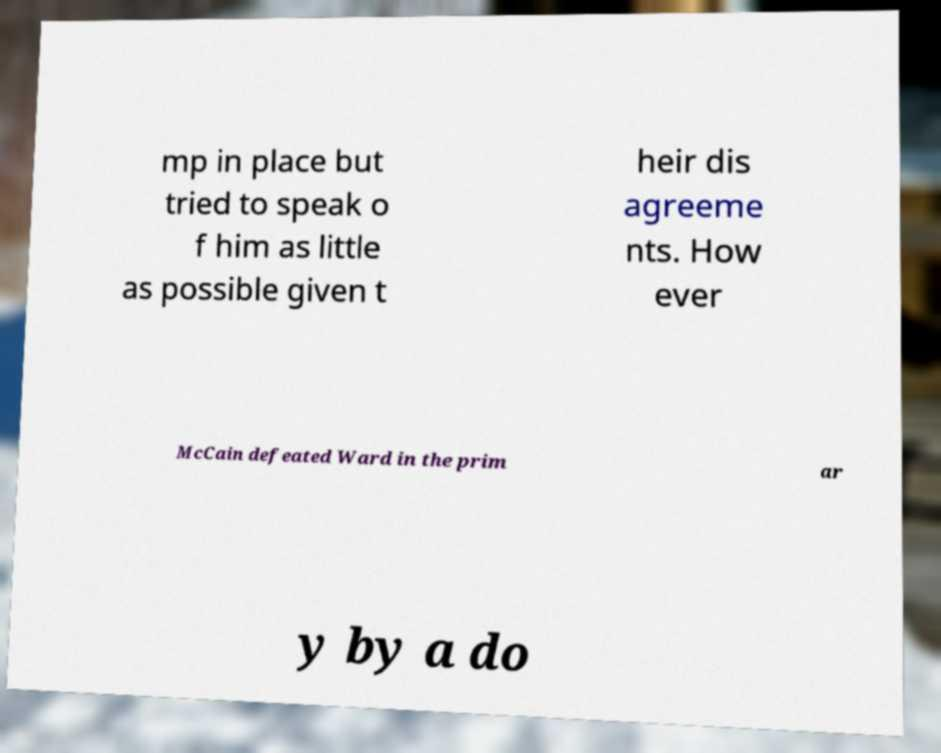There's text embedded in this image that I need extracted. Can you transcribe it verbatim? mp in place but tried to speak o f him as little as possible given t heir dis agreeme nts. How ever McCain defeated Ward in the prim ar y by a do 